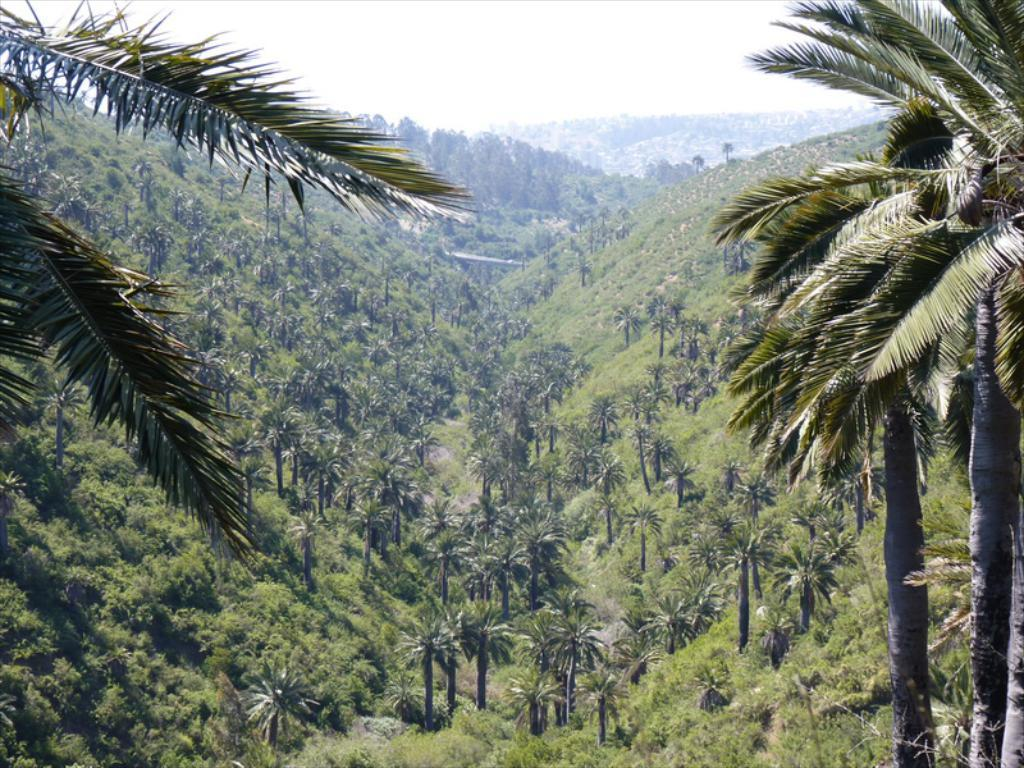What type of vegetation is present in the image? There are trees and plants in the image. What type of natural landform can be seen in the image? There are mountains in the image. What part of the natural environment is visible in the image? The sky is visible in the image. How many pigs are visible in the image? There are no pigs present in the image. What type of art can be seen hanging on the trees in the image? There is no art present in the image. Can you tell me where the bear is located in the image? There is no bear present in the image. 